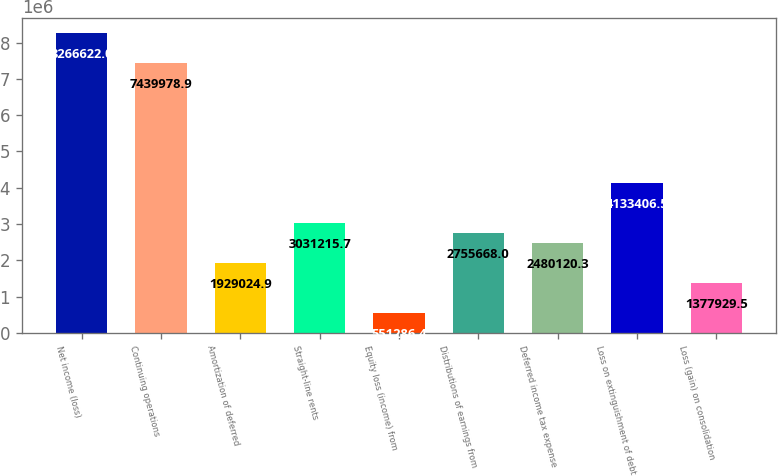Convert chart to OTSL. <chart><loc_0><loc_0><loc_500><loc_500><bar_chart><fcel>Net income (loss)<fcel>Continuing operations<fcel>Amortization of deferred<fcel>Straight-line rents<fcel>Equity loss (income) from<fcel>Distributions of earnings from<fcel>Deferred income tax expense<fcel>Loss on extinguishment of debt<fcel>Loss (gain) on consolidation<nl><fcel>8.26662e+06<fcel>7.43998e+06<fcel>1.92902e+06<fcel>3.03122e+06<fcel>551286<fcel>2.75567e+06<fcel>2.48012e+06<fcel>4.13341e+06<fcel>1.37793e+06<nl></chart> 